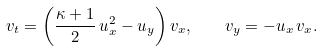<formula> <loc_0><loc_0><loc_500><loc_500>v _ { t } = \left ( \frac { \kappa + 1 } { 2 } \, u _ { x } ^ { 2 } - u _ { y } \right ) v _ { x } , \quad v _ { y } = - u _ { x } \, v _ { x } .</formula> 